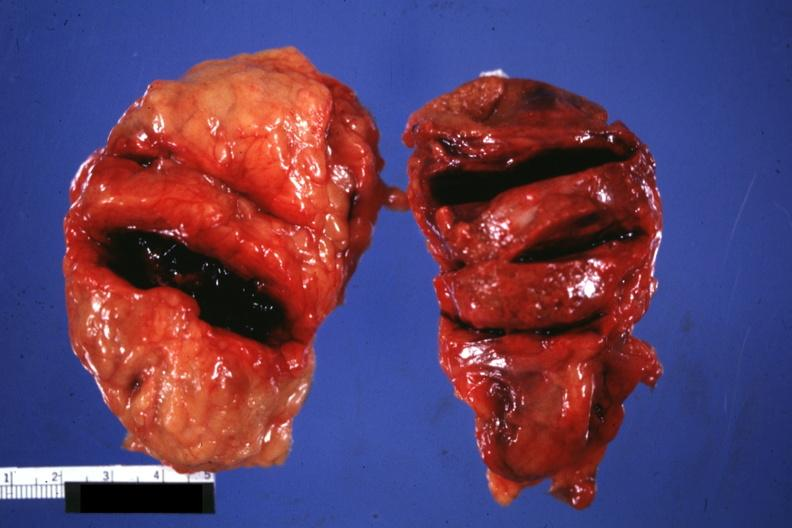where does this belong to?
Answer the question using a single word or phrase. Endocrine system 